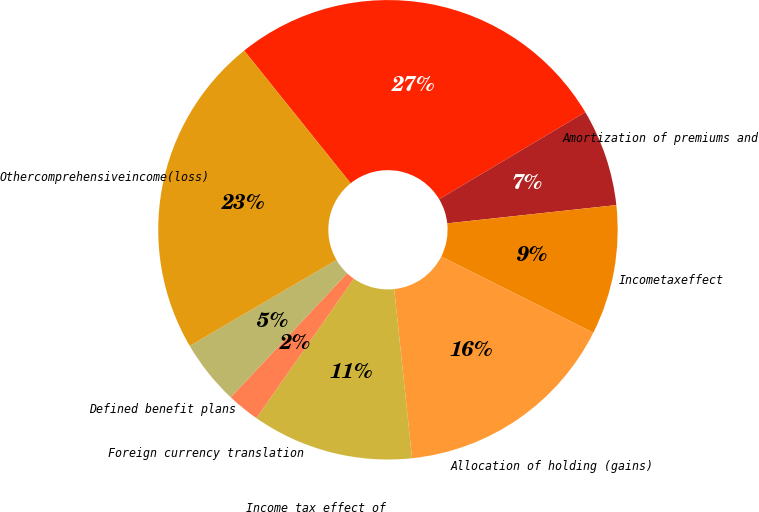<chart> <loc_0><loc_0><loc_500><loc_500><pie_chart><ecel><fcel>Amortization of premiums and<fcel>Incometaxeffect<fcel>Allocation of holding (gains)<fcel>Income tax effect of<fcel>Foreign currency translation<fcel>Defined benefit plans<fcel>Othercomprehensiveincome(loss)<nl><fcel>27.21%<fcel>6.84%<fcel>9.11%<fcel>15.93%<fcel>11.38%<fcel>2.29%<fcel>4.57%<fcel>22.67%<nl></chart> 